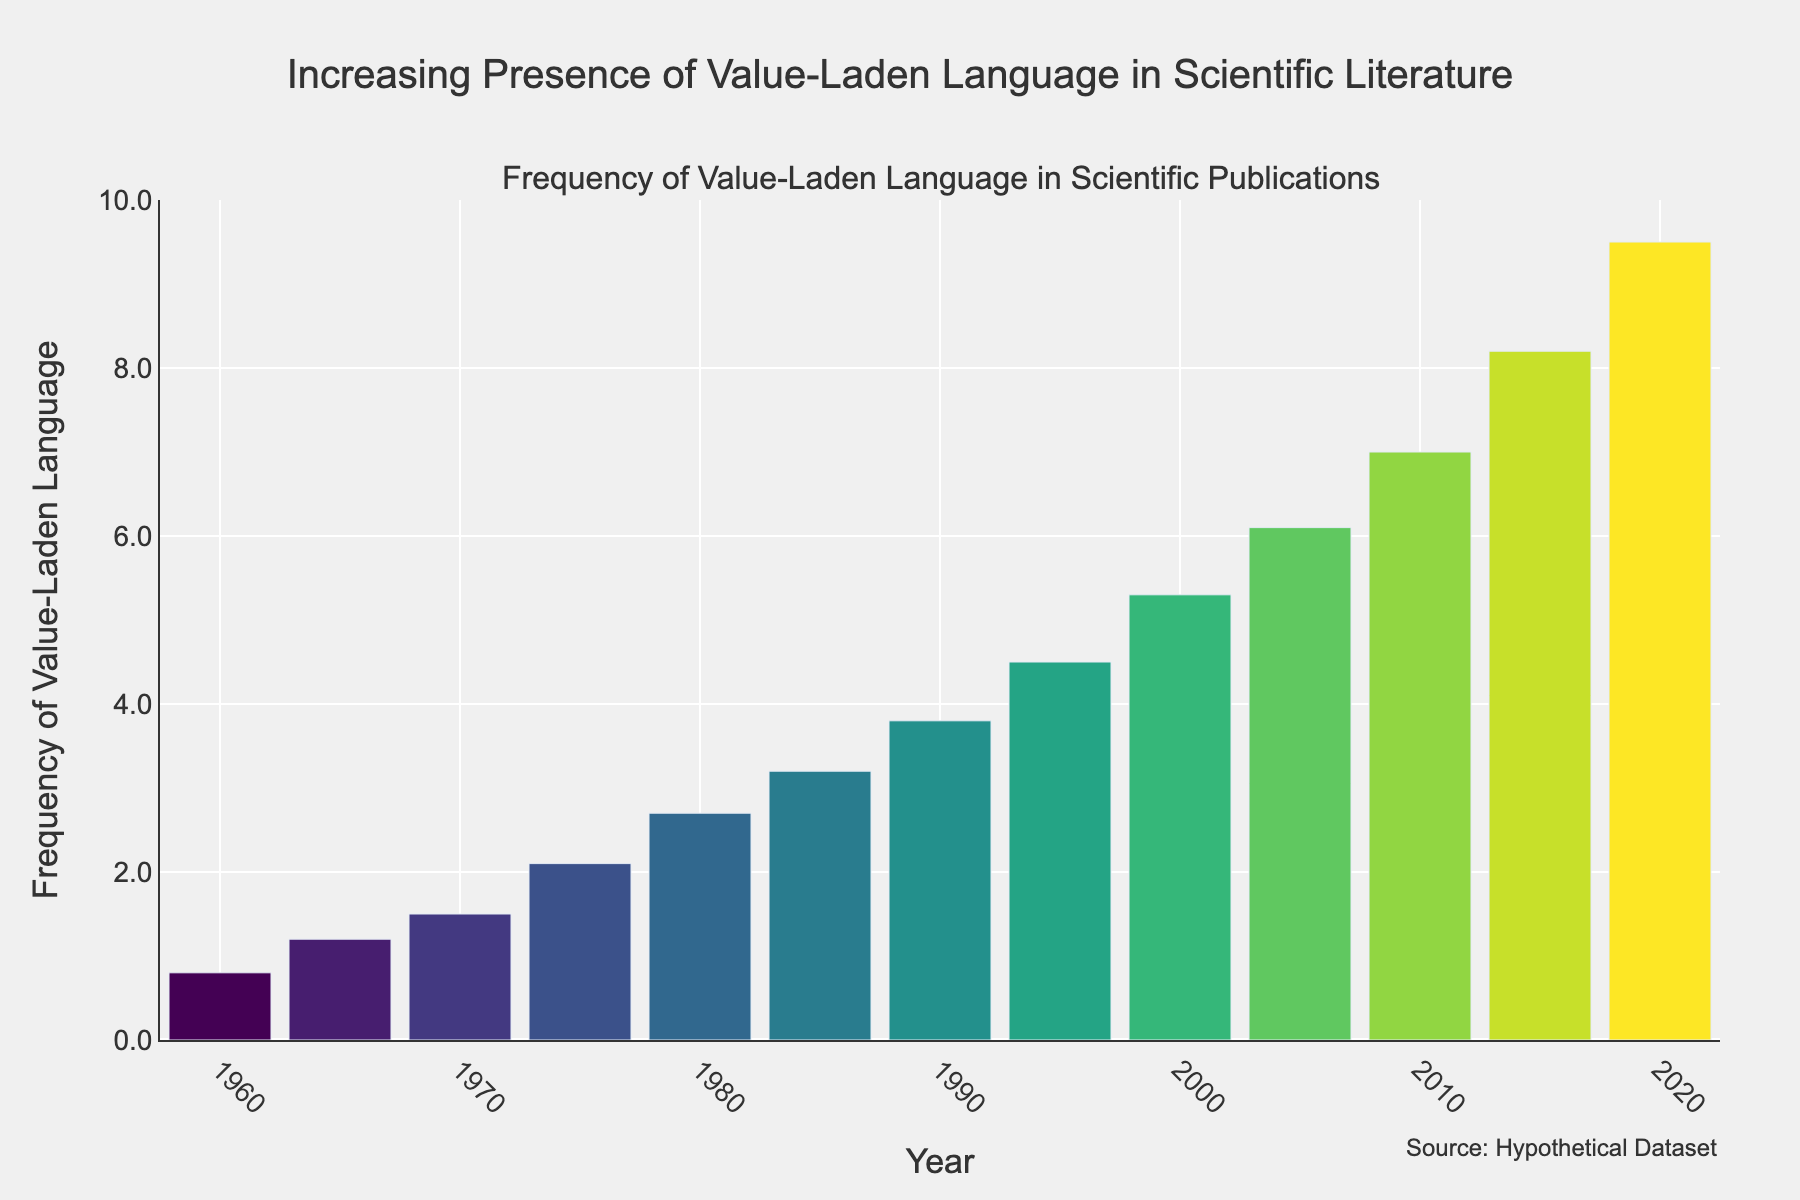When did the frequency of value-laden language first exceed 5.0? Look for the first year where the bar height exceeds 5.0 on the y-axis. The year is 2000.
Answer: 2000 What's the average frequency of value-laden language between 1980 and 1990 inclusive? Calculate the average of values in the 1980, 1985, and 1990 bars: (2.7 + 3.2 + 3.8)/3 = 3.23.
Answer: 3.2 How much did the frequency of value-laden language increase from 1960 to 2020? Subtract the frequency in 1960 from the frequency in 2020: 9.5 - 0.8 = 8.7.
Answer: 8.7 Which period had the steepest increase in the frequency of value-laden language? Visually inspect the difference in heights of adjacent bars. The largest increase appears between 2015 and 2020: 8.2 to 9.5.
Answer: 2015 to 2020 What is the difference in frequency between the years 1995 and 2005? Subtract the frequency in 1995 from the frequency in 2005: 6.1 - 4.5 = 1.6.
Answer: 1.6 During which decade did the frequency more than double compared to the previous decade? Compare the frequency change decade by decade. The frequency in 1975 (2.1) is more than double of 1965 (1.2).
Answer: 1970s What is the median frequency of value-laden language for the whole period? Order the frequencies and find the middle value. For 13 data points, the middle value is at position 7 (3.8).
Answer: 3.8 Compare the frequency change between the 1960s and 1970s. Calculate the changes: (1970 - 1960 = 0.7) and (1980 - 1970 = 1.2).
Answer: 0.7 and 1.2 Which year had a frequency closest to the average frequency over the entire period? Calculate the average frequency: (sum of all frequencies/13 = 4.23). The year closest to this value is 1985 (3.2).
Answer: 1985 